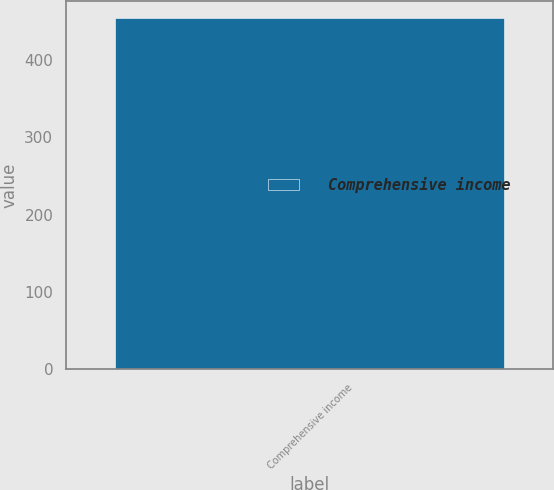Convert chart. <chart><loc_0><loc_0><loc_500><loc_500><bar_chart><fcel>Comprehensive income<nl><fcel>454<nl></chart> 